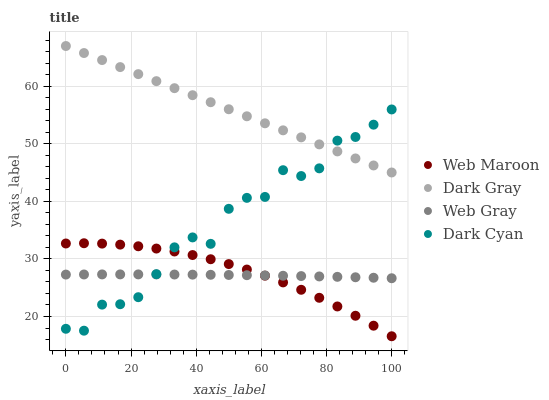Does Web Gray have the minimum area under the curve?
Answer yes or no. Yes. Does Dark Gray have the maximum area under the curve?
Answer yes or no. Yes. Does Dark Cyan have the minimum area under the curve?
Answer yes or no. No. Does Dark Cyan have the maximum area under the curve?
Answer yes or no. No. Is Dark Gray the smoothest?
Answer yes or no. Yes. Is Dark Cyan the roughest?
Answer yes or no. Yes. Is Web Gray the smoothest?
Answer yes or no. No. Is Web Gray the roughest?
Answer yes or no. No. Does Web Maroon have the lowest value?
Answer yes or no. Yes. Does Dark Cyan have the lowest value?
Answer yes or no. No. Does Dark Gray have the highest value?
Answer yes or no. Yes. Does Dark Cyan have the highest value?
Answer yes or no. No. Is Web Gray less than Dark Gray?
Answer yes or no. Yes. Is Dark Gray greater than Web Maroon?
Answer yes or no. Yes. Does Web Maroon intersect Web Gray?
Answer yes or no. Yes. Is Web Maroon less than Web Gray?
Answer yes or no. No. Is Web Maroon greater than Web Gray?
Answer yes or no. No. Does Web Gray intersect Dark Gray?
Answer yes or no. No. 